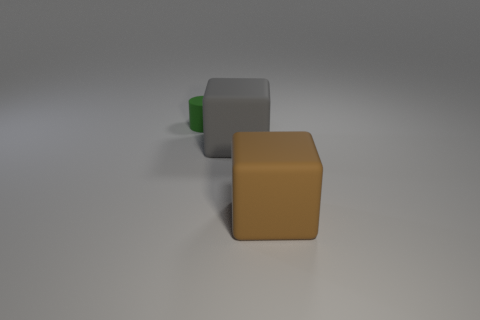Are there any other things that are the same size as the green matte thing?
Your answer should be compact. No. There is a block to the right of the big rubber object to the left of the large brown rubber thing; are there any cubes that are on the left side of it?
Your response must be concise. Yes. The big matte thing to the right of the big cube behind the block in front of the large gray rubber cube is what color?
Offer a very short reply. Brown. There is another large object that is the same shape as the large gray rubber thing; what material is it?
Offer a very short reply. Rubber. What size is the cylinder that is behind the block that is on the right side of the big gray cube?
Provide a short and direct response. Small. What is the material of the big object that is in front of the big gray matte block?
Your answer should be compact. Rubber. What size is the gray thing that is the same material as the green cylinder?
Make the answer very short. Large. What number of other big matte things have the same shape as the big gray rubber thing?
Provide a succinct answer. 1. Is the shape of the big brown rubber object the same as the large rubber thing on the left side of the brown object?
Make the answer very short. Yes. Are there any big blue cylinders that have the same material as the brown thing?
Keep it short and to the point. No. 